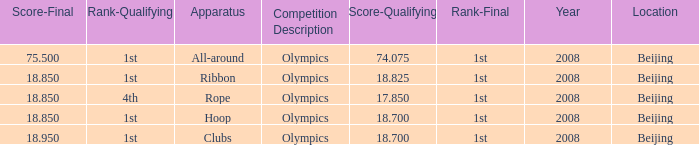7? Rope. 